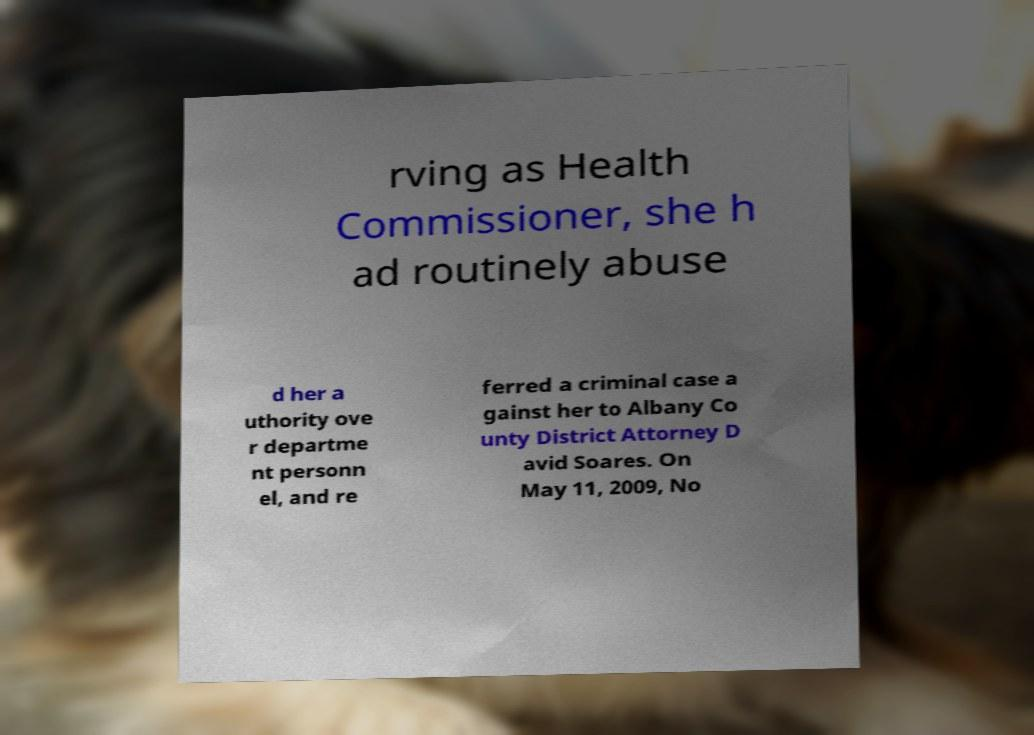I need the written content from this picture converted into text. Can you do that? rving as Health Commissioner, she h ad routinely abuse d her a uthority ove r departme nt personn el, and re ferred a criminal case a gainst her to Albany Co unty District Attorney D avid Soares. On May 11, 2009, No 